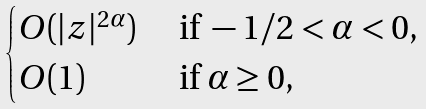<formula> <loc_0><loc_0><loc_500><loc_500>\begin{cases} O ( | z | ^ { 2 \alpha } ) & \text { if } - 1 / 2 < \alpha < 0 , \\ O ( 1 ) & \text { if } \alpha \geq 0 , \end{cases}</formula> 